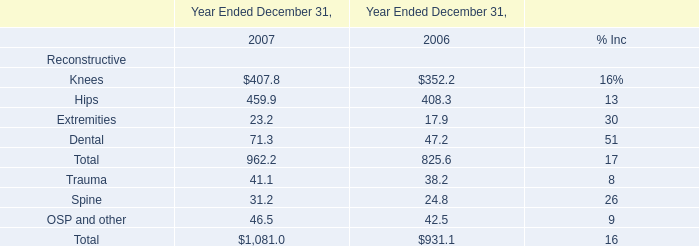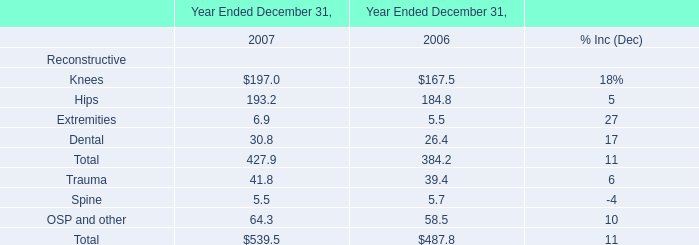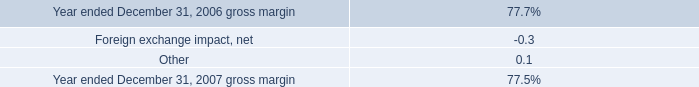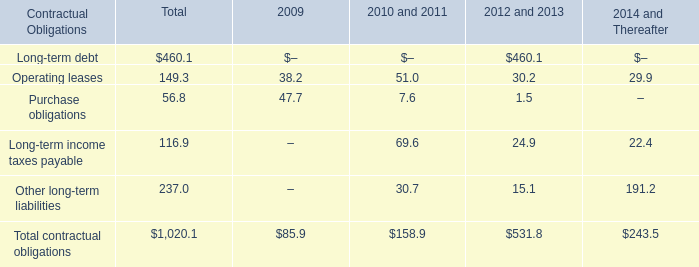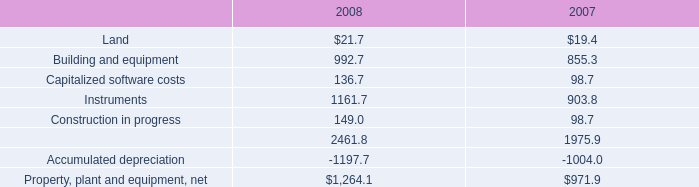Does the average value of Land in 2008 greater than that in 2007? 
Answer: yes. 